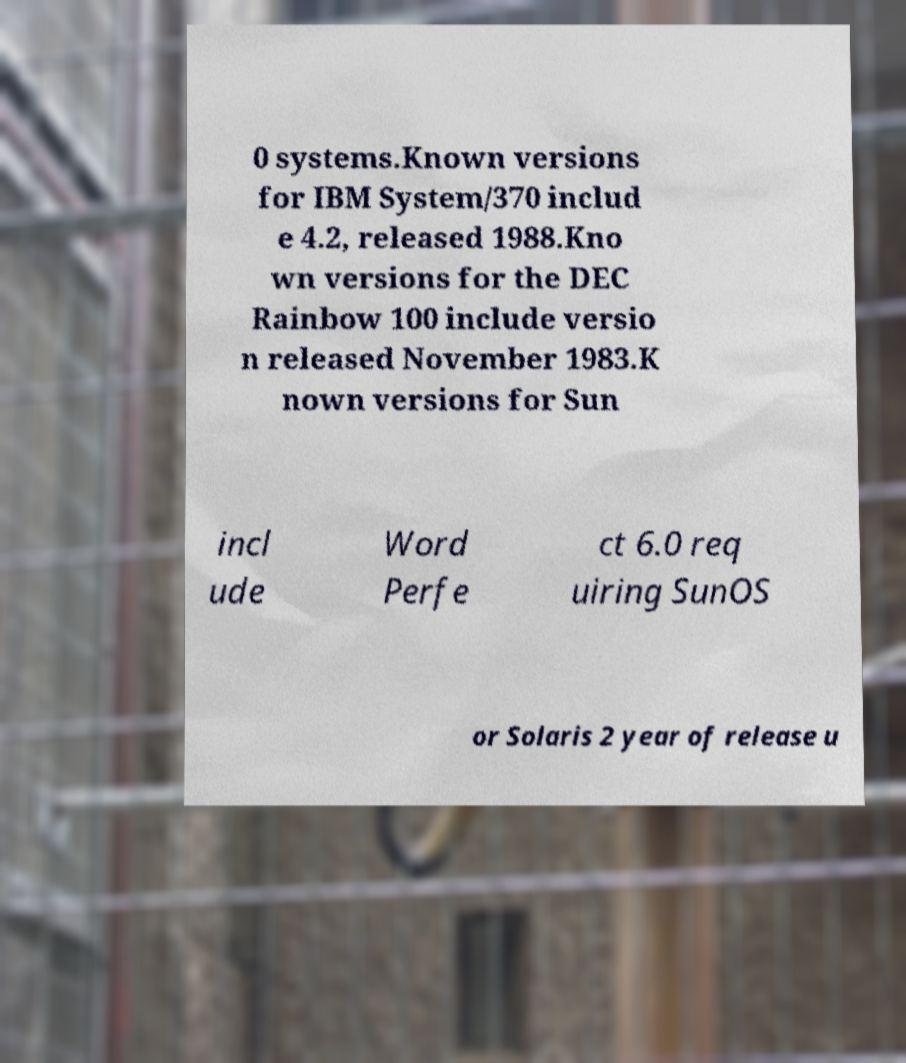Please read and relay the text visible in this image. What does it say? 0 systems.Known versions for IBM System/370 includ e 4.2, released 1988.Kno wn versions for the DEC Rainbow 100 include versio n released November 1983.K nown versions for Sun incl ude Word Perfe ct 6.0 req uiring SunOS or Solaris 2 year of release u 